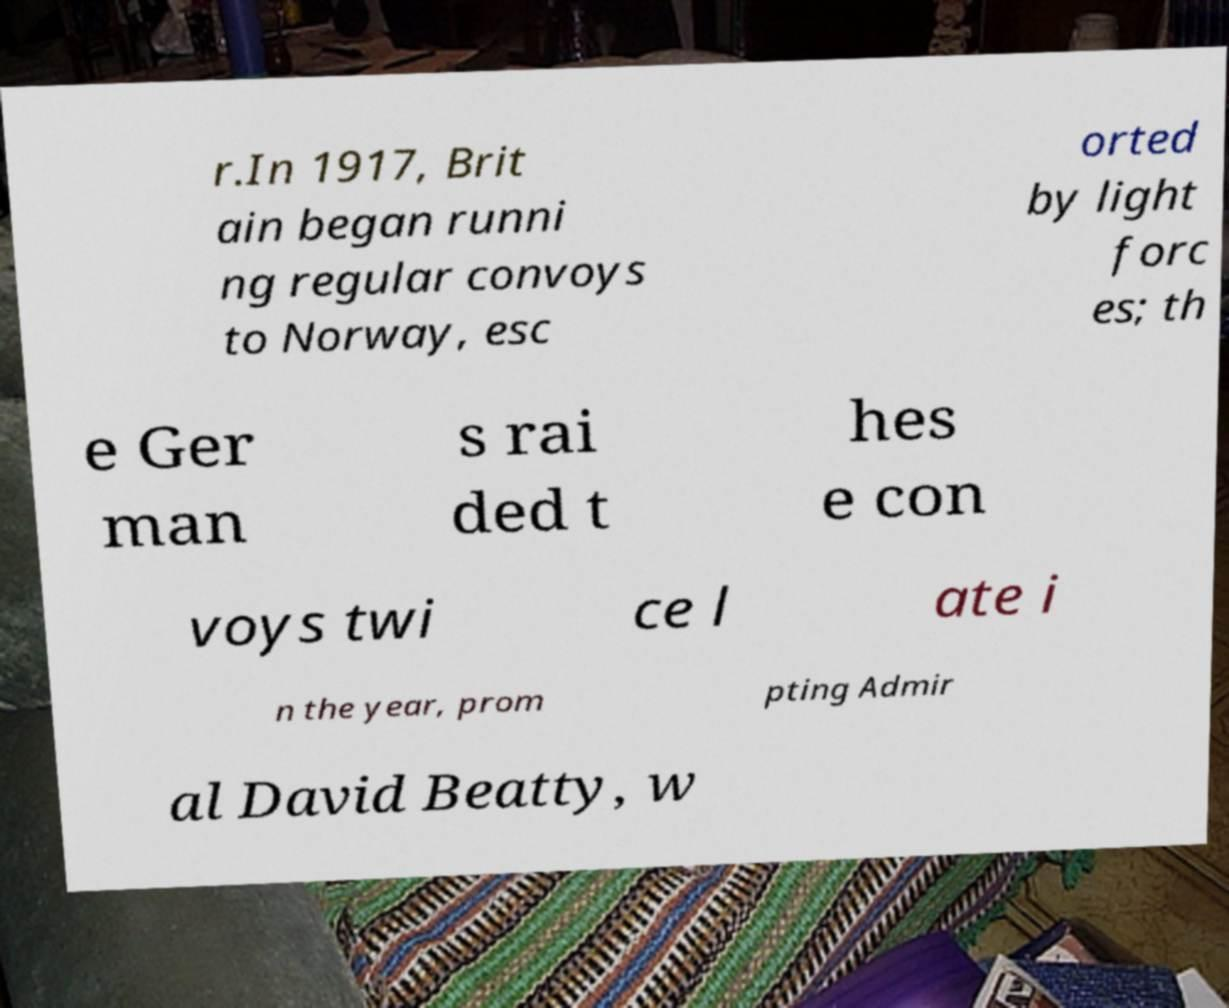I need the written content from this picture converted into text. Can you do that? r.In 1917, Brit ain began runni ng regular convoys to Norway, esc orted by light forc es; th e Ger man s rai ded t hes e con voys twi ce l ate i n the year, prom pting Admir al David Beatty, w 